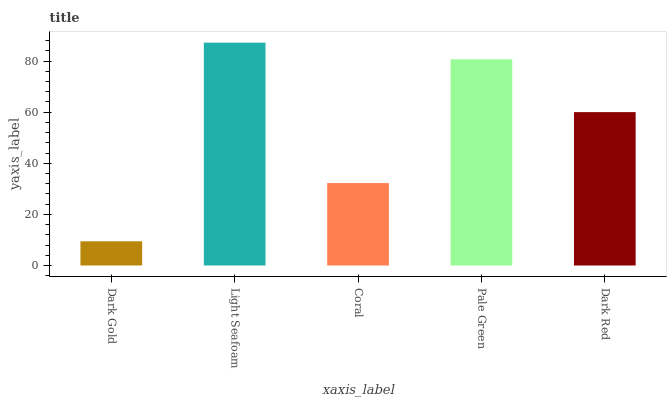Is Coral the minimum?
Answer yes or no. No. Is Coral the maximum?
Answer yes or no. No. Is Light Seafoam greater than Coral?
Answer yes or no. Yes. Is Coral less than Light Seafoam?
Answer yes or no. Yes. Is Coral greater than Light Seafoam?
Answer yes or no. No. Is Light Seafoam less than Coral?
Answer yes or no. No. Is Dark Red the high median?
Answer yes or no. Yes. Is Dark Red the low median?
Answer yes or no. Yes. Is Dark Gold the high median?
Answer yes or no. No. Is Light Seafoam the low median?
Answer yes or no. No. 